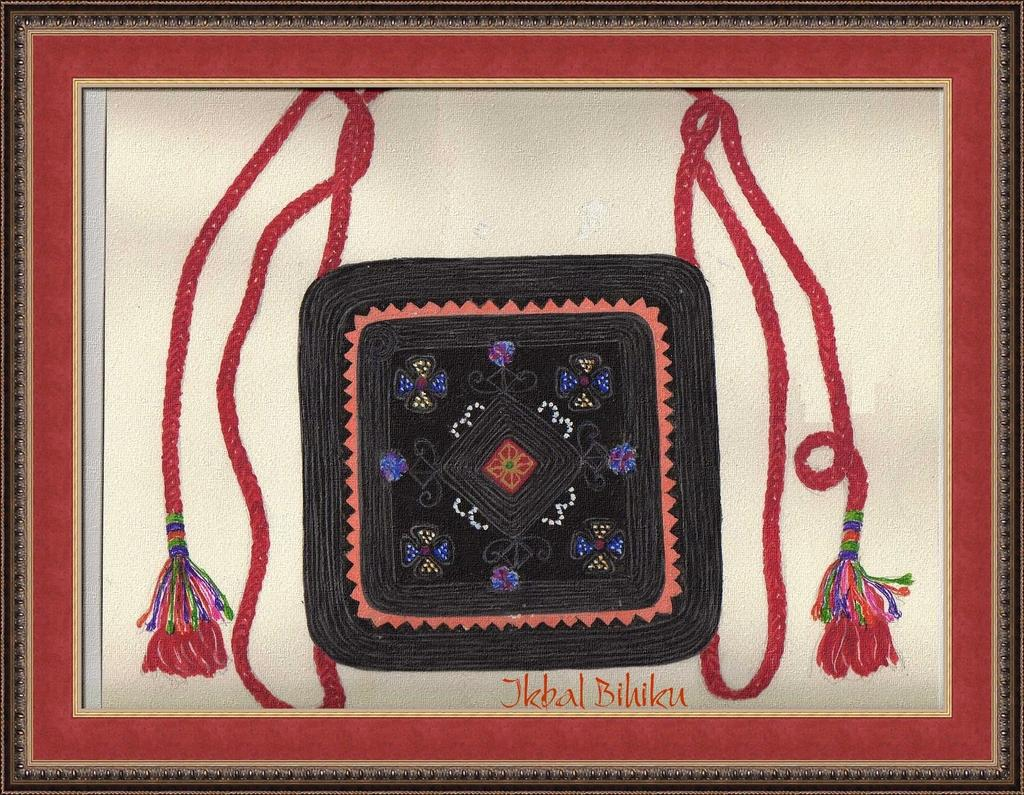<image>
Create a compact narrative representing the image presented. A piece of artwork created by Jkbal Bihiku is in a frame. 